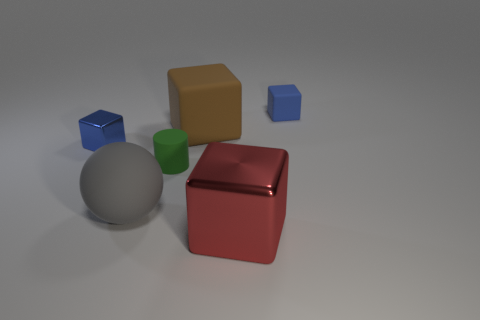Subtract all brown blocks. How many blocks are left? 3 Subtract all yellow blocks. Subtract all brown balls. How many blocks are left? 4 Add 2 small purple metallic spheres. How many objects exist? 8 Subtract all cylinders. How many objects are left? 5 Subtract 0 green blocks. How many objects are left? 6 Subtract all small green cubes. Subtract all big shiny cubes. How many objects are left? 5 Add 6 red metallic things. How many red metallic things are left? 7 Add 2 blue metallic things. How many blue metallic things exist? 3 